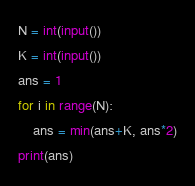<code> <loc_0><loc_0><loc_500><loc_500><_Python_>N = int(input())
K = int(input())
ans = 1
for i in range(N):
    ans = min(ans+K, ans*2)
print(ans)
</code> 